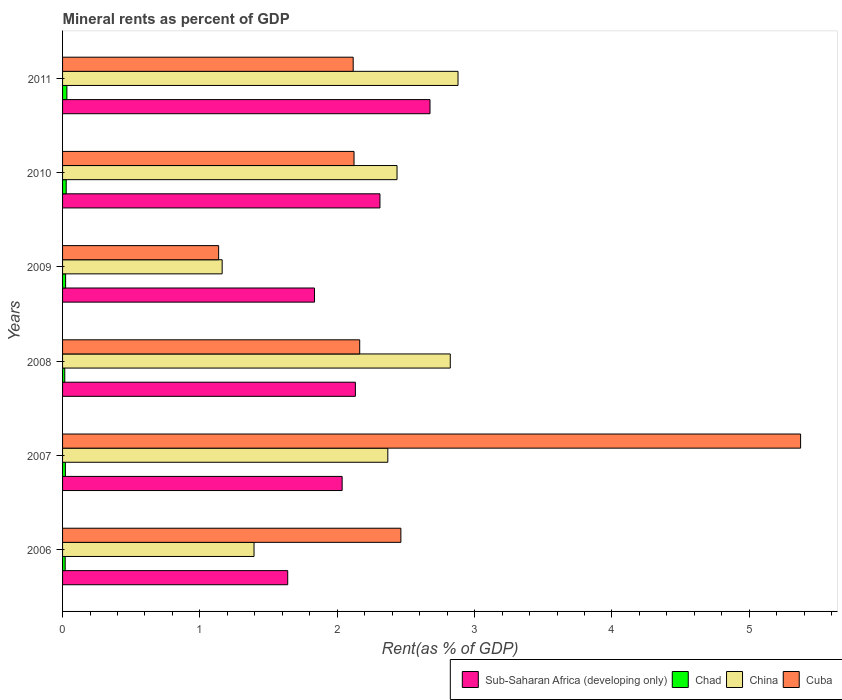How many different coloured bars are there?
Offer a terse response. 4. Are the number of bars per tick equal to the number of legend labels?
Keep it short and to the point. Yes. Are the number of bars on each tick of the Y-axis equal?
Keep it short and to the point. Yes. How many bars are there on the 1st tick from the bottom?
Your response must be concise. 4. What is the label of the 3rd group of bars from the top?
Give a very brief answer. 2009. What is the mineral rent in Cuba in 2008?
Your answer should be compact. 2.16. Across all years, what is the maximum mineral rent in Cuba?
Keep it short and to the point. 5.37. Across all years, what is the minimum mineral rent in China?
Offer a terse response. 1.16. What is the total mineral rent in China in the graph?
Keep it short and to the point. 13.06. What is the difference between the mineral rent in Sub-Saharan Africa (developing only) in 2006 and that in 2011?
Make the answer very short. -1.04. What is the difference between the mineral rent in Chad in 2006 and the mineral rent in China in 2009?
Offer a terse response. -1.14. What is the average mineral rent in Sub-Saharan Africa (developing only) per year?
Give a very brief answer. 2.1. In the year 2010, what is the difference between the mineral rent in Cuba and mineral rent in China?
Ensure brevity in your answer.  -0.31. In how many years, is the mineral rent in Chad greater than 1.8 %?
Provide a short and direct response. 0. What is the ratio of the mineral rent in Chad in 2006 to that in 2007?
Your answer should be compact. 0.93. What is the difference between the highest and the second highest mineral rent in Cuba?
Your answer should be very brief. 2.91. What is the difference between the highest and the lowest mineral rent in China?
Provide a succinct answer. 1.72. In how many years, is the mineral rent in Cuba greater than the average mineral rent in Cuba taken over all years?
Provide a short and direct response. 1. What does the 4th bar from the top in 2008 represents?
Keep it short and to the point. Sub-Saharan Africa (developing only). What does the 4th bar from the bottom in 2009 represents?
Make the answer very short. Cuba. How many bars are there?
Provide a short and direct response. 24. How many years are there in the graph?
Provide a short and direct response. 6. Does the graph contain grids?
Your answer should be compact. No. How many legend labels are there?
Your answer should be very brief. 4. What is the title of the graph?
Ensure brevity in your answer.  Mineral rents as percent of GDP. What is the label or title of the X-axis?
Ensure brevity in your answer.  Rent(as % of GDP). What is the label or title of the Y-axis?
Provide a short and direct response. Years. What is the Rent(as % of GDP) of Sub-Saharan Africa (developing only) in 2006?
Your answer should be very brief. 1.64. What is the Rent(as % of GDP) of Chad in 2006?
Keep it short and to the point. 0.02. What is the Rent(as % of GDP) in China in 2006?
Provide a short and direct response. 1.39. What is the Rent(as % of GDP) of Cuba in 2006?
Offer a very short reply. 2.46. What is the Rent(as % of GDP) in Sub-Saharan Africa (developing only) in 2007?
Provide a succinct answer. 2.04. What is the Rent(as % of GDP) of Chad in 2007?
Give a very brief answer. 0.02. What is the Rent(as % of GDP) in China in 2007?
Your answer should be very brief. 2.37. What is the Rent(as % of GDP) of Cuba in 2007?
Keep it short and to the point. 5.37. What is the Rent(as % of GDP) in Sub-Saharan Africa (developing only) in 2008?
Your response must be concise. 2.13. What is the Rent(as % of GDP) of Chad in 2008?
Make the answer very short. 0.02. What is the Rent(as % of GDP) in China in 2008?
Give a very brief answer. 2.82. What is the Rent(as % of GDP) in Cuba in 2008?
Keep it short and to the point. 2.16. What is the Rent(as % of GDP) in Sub-Saharan Africa (developing only) in 2009?
Give a very brief answer. 1.83. What is the Rent(as % of GDP) in Chad in 2009?
Offer a very short reply. 0.02. What is the Rent(as % of GDP) in China in 2009?
Provide a succinct answer. 1.16. What is the Rent(as % of GDP) in Cuba in 2009?
Make the answer very short. 1.14. What is the Rent(as % of GDP) of Sub-Saharan Africa (developing only) in 2010?
Your answer should be compact. 2.31. What is the Rent(as % of GDP) in Chad in 2010?
Your answer should be compact. 0.03. What is the Rent(as % of GDP) in China in 2010?
Your answer should be compact. 2.44. What is the Rent(as % of GDP) in Cuba in 2010?
Ensure brevity in your answer.  2.12. What is the Rent(as % of GDP) in Sub-Saharan Africa (developing only) in 2011?
Provide a succinct answer. 2.68. What is the Rent(as % of GDP) of Chad in 2011?
Make the answer very short. 0.03. What is the Rent(as % of GDP) of China in 2011?
Offer a very short reply. 2.88. What is the Rent(as % of GDP) of Cuba in 2011?
Your answer should be compact. 2.12. Across all years, what is the maximum Rent(as % of GDP) of Sub-Saharan Africa (developing only)?
Provide a short and direct response. 2.68. Across all years, what is the maximum Rent(as % of GDP) in Chad?
Your response must be concise. 0.03. Across all years, what is the maximum Rent(as % of GDP) in China?
Provide a succinct answer. 2.88. Across all years, what is the maximum Rent(as % of GDP) of Cuba?
Your response must be concise. 5.37. Across all years, what is the minimum Rent(as % of GDP) in Sub-Saharan Africa (developing only)?
Make the answer very short. 1.64. Across all years, what is the minimum Rent(as % of GDP) of Chad?
Provide a succinct answer. 0.02. Across all years, what is the minimum Rent(as % of GDP) of China?
Your response must be concise. 1.16. Across all years, what is the minimum Rent(as % of GDP) in Cuba?
Your response must be concise. 1.14. What is the total Rent(as % of GDP) in Sub-Saharan Africa (developing only) in the graph?
Provide a succinct answer. 12.63. What is the total Rent(as % of GDP) of Chad in the graph?
Provide a short and direct response. 0.14. What is the total Rent(as % of GDP) in China in the graph?
Keep it short and to the point. 13.06. What is the total Rent(as % of GDP) of Cuba in the graph?
Make the answer very short. 15.37. What is the difference between the Rent(as % of GDP) of Sub-Saharan Africa (developing only) in 2006 and that in 2007?
Keep it short and to the point. -0.4. What is the difference between the Rent(as % of GDP) in Chad in 2006 and that in 2007?
Give a very brief answer. -0. What is the difference between the Rent(as % of GDP) of China in 2006 and that in 2007?
Your answer should be very brief. -0.97. What is the difference between the Rent(as % of GDP) in Cuba in 2006 and that in 2007?
Your answer should be compact. -2.91. What is the difference between the Rent(as % of GDP) of Sub-Saharan Africa (developing only) in 2006 and that in 2008?
Offer a terse response. -0.49. What is the difference between the Rent(as % of GDP) of Chad in 2006 and that in 2008?
Ensure brevity in your answer.  0. What is the difference between the Rent(as % of GDP) of China in 2006 and that in 2008?
Your response must be concise. -1.43. What is the difference between the Rent(as % of GDP) of Cuba in 2006 and that in 2008?
Provide a short and direct response. 0.3. What is the difference between the Rent(as % of GDP) of Sub-Saharan Africa (developing only) in 2006 and that in 2009?
Make the answer very short. -0.19. What is the difference between the Rent(as % of GDP) of Chad in 2006 and that in 2009?
Offer a terse response. -0. What is the difference between the Rent(as % of GDP) in China in 2006 and that in 2009?
Give a very brief answer. 0.23. What is the difference between the Rent(as % of GDP) of Cuba in 2006 and that in 2009?
Keep it short and to the point. 1.33. What is the difference between the Rent(as % of GDP) in Sub-Saharan Africa (developing only) in 2006 and that in 2010?
Provide a succinct answer. -0.67. What is the difference between the Rent(as % of GDP) of Chad in 2006 and that in 2010?
Give a very brief answer. -0.01. What is the difference between the Rent(as % of GDP) in China in 2006 and that in 2010?
Your answer should be very brief. -1.04. What is the difference between the Rent(as % of GDP) of Cuba in 2006 and that in 2010?
Make the answer very short. 0.34. What is the difference between the Rent(as % of GDP) in Sub-Saharan Africa (developing only) in 2006 and that in 2011?
Provide a succinct answer. -1.04. What is the difference between the Rent(as % of GDP) in Chad in 2006 and that in 2011?
Provide a succinct answer. -0.01. What is the difference between the Rent(as % of GDP) of China in 2006 and that in 2011?
Provide a succinct answer. -1.49. What is the difference between the Rent(as % of GDP) in Cuba in 2006 and that in 2011?
Offer a terse response. 0.35. What is the difference between the Rent(as % of GDP) in Sub-Saharan Africa (developing only) in 2007 and that in 2008?
Provide a succinct answer. -0.1. What is the difference between the Rent(as % of GDP) of Chad in 2007 and that in 2008?
Provide a succinct answer. 0. What is the difference between the Rent(as % of GDP) of China in 2007 and that in 2008?
Make the answer very short. -0.45. What is the difference between the Rent(as % of GDP) in Cuba in 2007 and that in 2008?
Provide a succinct answer. 3.21. What is the difference between the Rent(as % of GDP) in Sub-Saharan Africa (developing only) in 2007 and that in 2009?
Give a very brief answer. 0.2. What is the difference between the Rent(as % of GDP) of Chad in 2007 and that in 2009?
Give a very brief answer. -0. What is the difference between the Rent(as % of GDP) of China in 2007 and that in 2009?
Make the answer very short. 1.21. What is the difference between the Rent(as % of GDP) in Cuba in 2007 and that in 2009?
Provide a short and direct response. 4.24. What is the difference between the Rent(as % of GDP) of Sub-Saharan Africa (developing only) in 2007 and that in 2010?
Make the answer very short. -0.28. What is the difference between the Rent(as % of GDP) of Chad in 2007 and that in 2010?
Provide a succinct answer. -0.01. What is the difference between the Rent(as % of GDP) of China in 2007 and that in 2010?
Give a very brief answer. -0.07. What is the difference between the Rent(as % of GDP) in Cuba in 2007 and that in 2010?
Offer a terse response. 3.25. What is the difference between the Rent(as % of GDP) of Sub-Saharan Africa (developing only) in 2007 and that in 2011?
Your answer should be very brief. -0.64. What is the difference between the Rent(as % of GDP) in Chad in 2007 and that in 2011?
Your answer should be very brief. -0.01. What is the difference between the Rent(as % of GDP) of China in 2007 and that in 2011?
Make the answer very short. -0.51. What is the difference between the Rent(as % of GDP) in Cuba in 2007 and that in 2011?
Your response must be concise. 3.26. What is the difference between the Rent(as % of GDP) of Sub-Saharan Africa (developing only) in 2008 and that in 2009?
Keep it short and to the point. 0.3. What is the difference between the Rent(as % of GDP) of Chad in 2008 and that in 2009?
Give a very brief answer. -0.01. What is the difference between the Rent(as % of GDP) in China in 2008 and that in 2009?
Your answer should be compact. 1.66. What is the difference between the Rent(as % of GDP) in Cuba in 2008 and that in 2009?
Keep it short and to the point. 1.03. What is the difference between the Rent(as % of GDP) of Sub-Saharan Africa (developing only) in 2008 and that in 2010?
Offer a very short reply. -0.18. What is the difference between the Rent(as % of GDP) in Chad in 2008 and that in 2010?
Offer a very short reply. -0.01. What is the difference between the Rent(as % of GDP) of China in 2008 and that in 2010?
Your response must be concise. 0.39. What is the difference between the Rent(as % of GDP) of Cuba in 2008 and that in 2010?
Give a very brief answer. 0.04. What is the difference between the Rent(as % of GDP) in Sub-Saharan Africa (developing only) in 2008 and that in 2011?
Your answer should be very brief. -0.54. What is the difference between the Rent(as % of GDP) in Chad in 2008 and that in 2011?
Provide a short and direct response. -0.02. What is the difference between the Rent(as % of GDP) in China in 2008 and that in 2011?
Offer a very short reply. -0.06. What is the difference between the Rent(as % of GDP) in Cuba in 2008 and that in 2011?
Offer a terse response. 0.05. What is the difference between the Rent(as % of GDP) in Sub-Saharan Africa (developing only) in 2009 and that in 2010?
Your answer should be very brief. -0.48. What is the difference between the Rent(as % of GDP) in Chad in 2009 and that in 2010?
Ensure brevity in your answer.  -0. What is the difference between the Rent(as % of GDP) in China in 2009 and that in 2010?
Offer a terse response. -1.27. What is the difference between the Rent(as % of GDP) of Cuba in 2009 and that in 2010?
Ensure brevity in your answer.  -0.99. What is the difference between the Rent(as % of GDP) in Sub-Saharan Africa (developing only) in 2009 and that in 2011?
Keep it short and to the point. -0.84. What is the difference between the Rent(as % of GDP) in Chad in 2009 and that in 2011?
Offer a very short reply. -0.01. What is the difference between the Rent(as % of GDP) in China in 2009 and that in 2011?
Ensure brevity in your answer.  -1.72. What is the difference between the Rent(as % of GDP) in Cuba in 2009 and that in 2011?
Offer a terse response. -0.98. What is the difference between the Rent(as % of GDP) of Sub-Saharan Africa (developing only) in 2010 and that in 2011?
Ensure brevity in your answer.  -0.36. What is the difference between the Rent(as % of GDP) of Chad in 2010 and that in 2011?
Make the answer very short. -0.01. What is the difference between the Rent(as % of GDP) of China in 2010 and that in 2011?
Provide a short and direct response. -0.44. What is the difference between the Rent(as % of GDP) in Cuba in 2010 and that in 2011?
Offer a very short reply. 0.01. What is the difference between the Rent(as % of GDP) of Sub-Saharan Africa (developing only) in 2006 and the Rent(as % of GDP) of Chad in 2007?
Give a very brief answer. 1.62. What is the difference between the Rent(as % of GDP) in Sub-Saharan Africa (developing only) in 2006 and the Rent(as % of GDP) in China in 2007?
Offer a terse response. -0.73. What is the difference between the Rent(as % of GDP) in Sub-Saharan Africa (developing only) in 2006 and the Rent(as % of GDP) in Cuba in 2007?
Your answer should be very brief. -3.73. What is the difference between the Rent(as % of GDP) in Chad in 2006 and the Rent(as % of GDP) in China in 2007?
Ensure brevity in your answer.  -2.35. What is the difference between the Rent(as % of GDP) in Chad in 2006 and the Rent(as % of GDP) in Cuba in 2007?
Keep it short and to the point. -5.35. What is the difference between the Rent(as % of GDP) of China in 2006 and the Rent(as % of GDP) of Cuba in 2007?
Keep it short and to the point. -3.98. What is the difference between the Rent(as % of GDP) in Sub-Saharan Africa (developing only) in 2006 and the Rent(as % of GDP) in Chad in 2008?
Offer a very short reply. 1.62. What is the difference between the Rent(as % of GDP) in Sub-Saharan Africa (developing only) in 2006 and the Rent(as % of GDP) in China in 2008?
Provide a short and direct response. -1.18. What is the difference between the Rent(as % of GDP) in Sub-Saharan Africa (developing only) in 2006 and the Rent(as % of GDP) in Cuba in 2008?
Keep it short and to the point. -0.52. What is the difference between the Rent(as % of GDP) in Chad in 2006 and the Rent(as % of GDP) in China in 2008?
Your response must be concise. -2.8. What is the difference between the Rent(as % of GDP) in Chad in 2006 and the Rent(as % of GDP) in Cuba in 2008?
Offer a terse response. -2.14. What is the difference between the Rent(as % of GDP) in China in 2006 and the Rent(as % of GDP) in Cuba in 2008?
Provide a succinct answer. -0.77. What is the difference between the Rent(as % of GDP) of Sub-Saharan Africa (developing only) in 2006 and the Rent(as % of GDP) of Chad in 2009?
Your answer should be very brief. 1.62. What is the difference between the Rent(as % of GDP) in Sub-Saharan Africa (developing only) in 2006 and the Rent(as % of GDP) in China in 2009?
Your answer should be very brief. 0.48. What is the difference between the Rent(as % of GDP) of Sub-Saharan Africa (developing only) in 2006 and the Rent(as % of GDP) of Cuba in 2009?
Your response must be concise. 0.5. What is the difference between the Rent(as % of GDP) of Chad in 2006 and the Rent(as % of GDP) of China in 2009?
Give a very brief answer. -1.14. What is the difference between the Rent(as % of GDP) in Chad in 2006 and the Rent(as % of GDP) in Cuba in 2009?
Keep it short and to the point. -1.12. What is the difference between the Rent(as % of GDP) in China in 2006 and the Rent(as % of GDP) in Cuba in 2009?
Ensure brevity in your answer.  0.26. What is the difference between the Rent(as % of GDP) of Sub-Saharan Africa (developing only) in 2006 and the Rent(as % of GDP) of Chad in 2010?
Your answer should be very brief. 1.61. What is the difference between the Rent(as % of GDP) in Sub-Saharan Africa (developing only) in 2006 and the Rent(as % of GDP) in China in 2010?
Your response must be concise. -0.8. What is the difference between the Rent(as % of GDP) of Sub-Saharan Africa (developing only) in 2006 and the Rent(as % of GDP) of Cuba in 2010?
Make the answer very short. -0.48. What is the difference between the Rent(as % of GDP) of Chad in 2006 and the Rent(as % of GDP) of China in 2010?
Keep it short and to the point. -2.42. What is the difference between the Rent(as % of GDP) of Chad in 2006 and the Rent(as % of GDP) of Cuba in 2010?
Keep it short and to the point. -2.1. What is the difference between the Rent(as % of GDP) in China in 2006 and the Rent(as % of GDP) in Cuba in 2010?
Your answer should be very brief. -0.73. What is the difference between the Rent(as % of GDP) in Sub-Saharan Africa (developing only) in 2006 and the Rent(as % of GDP) in Chad in 2011?
Give a very brief answer. 1.61. What is the difference between the Rent(as % of GDP) in Sub-Saharan Africa (developing only) in 2006 and the Rent(as % of GDP) in China in 2011?
Keep it short and to the point. -1.24. What is the difference between the Rent(as % of GDP) of Sub-Saharan Africa (developing only) in 2006 and the Rent(as % of GDP) of Cuba in 2011?
Your response must be concise. -0.48. What is the difference between the Rent(as % of GDP) in Chad in 2006 and the Rent(as % of GDP) in China in 2011?
Your answer should be compact. -2.86. What is the difference between the Rent(as % of GDP) of Chad in 2006 and the Rent(as % of GDP) of Cuba in 2011?
Give a very brief answer. -2.1. What is the difference between the Rent(as % of GDP) of China in 2006 and the Rent(as % of GDP) of Cuba in 2011?
Make the answer very short. -0.72. What is the difference between the Rent(as % of GDP) in Sub-Saharan Africa (developing only) in 2007 and the Rent(as % of GDP) in Chad in 2008?
Your answer should be very brief. 2.02. What is the difference between the Rent(as % of GDP) of Sub-Saharan Africa (developing only) in 2007 and the Rent(as % of GDP) of China in 2008?
Provide a short and direct response. -0.79. What is the difference between the Rent(as % of GDP) in Sub-Saharan Africa (developing only) in 2007 and the Rent(as % of GDP) in Cuba in 2008?
Your answer should be compact. -0.13. What is the difference between the Rent(as % of GDP) in Chad in 2007 and the Rent(as % of GDP) in China in 2008?
Provide a short and direct response. -2.8. What is the difference between the Rent(as % of GDP) in Chad in 2007 and the Rent(as % of GDP) in Cuba in 2008?
Ensure brevity in your answer.  -2.14. What is the difference between the Rent(as % of GDP) of China in 2007 and the Rent(as % of GDP) of Cuba in 2008?
Your answer should be very brief. 0.2. What is the difference between the Rent(as % of GDP) of Sub-Saharan Africa (developing only) in 2007 and the Rent(as % of GDP) of Chad in 2009?
Your answer should be very brief. 2.01. What is the difference between the Rent(as % of GDP) of Sub-Saharan Africa (developing only) in 2007 and the Rent(as % of GDP) of China in 2009?
Your response must be concise. 0.87. What is the difference between the Rent(as % of GDP) in Sub-Saharan Africa (developing only) in 2007 and the Rent(as % of GDP) in Cuba in 2009?
Provide a short and direct response. 0.9. What is the difference between the Rent(as % of GDP) in Chad in 2007 and the Rent(as % of GDP) in China in 2009?
Offer a very short reply. -1.14. What is the difference between the Rent(as % of GDP) of Chad in 2007 and the Rent(as % of GDP) of Cuba in 2009?
Ensure brevity in your answer.  -1.12. What is the difference between the Rent(as % of GDP) of China in 2007 and the Rent(as % of GDP) of Cuba in 2009?
Offer a terse response. 1.23. What is the difference between the Rent(as % of GDP) in Sub-Saharan Africa (developing only) in 2007 and the Rent(as % of GDP) in Chad in 2010?
Offer a terse response. 2.01. What is the difference between the Rent(as % of GDP) of Sub-Saharan Africa (developing only) in 2007 and the Rent(as % of GDP) of China in 2010?
Ensure brevity in your answer.  -0.4. What is the difference between the Rent(as % of GDP) in Sub-Saharan Africa (developing only) in 2007 and the Rent(as % of GDP) in Cuba in 2010?
Provide a short and direct response. -0.09. What is the difference between the Rent(as % of GDP) in Chad in 2007 and the Rent(as % of GDP) in China in 2010?
Your answer should be compact. -2.41. What is the difference between the Rent(as % of GDP) of Chad in 2007 and the Rent(as % of GDP) of Cuba in 2010?
Offer a terse response. -2.1. What is the difference between the Rent(as % of GDP) of China in 2007 and the Rent(as % of GDP) of Cuba in 2010?
Offer a terse response. 0.25. What is the difference between the Rent(as % of GDP) in Sub-Saharan Africa (developing only) in 2007 and the Rent(as % of GDP) in Chad in 2011?
Your response must be concise. 2. What is the difference between the Rent(as % of GDP) of Sub-Saharan Africa (developing only) in 2007 and the Rent(as % of GDP) of China in 2011?
Your answer should be very brief. -0.84. What is the difference between the Rent(as % of GDP) of Sub-Saharan Africa (developing only) in 2007 and the Rent(as % of GDP) of Cuba in 2011?
Provide a short and direct response. -0.08. What is the difference between the Rent(as % of GDP) in Chad in 2007 and the Rent(as % of GDP) in China in 2011?
Give a very brief answer. -2.86. What is the difference between the Rent(as % of GDP) of Chad in 2007 and the Rent(as % of GDP) of Cuba in 2011?
Provide a succinct answer. -2.1. What is the difference between the Rent(as % of GDP) in China in 2007 and the Rent(as % of GDP) in Cuba in 2011?
Your answer should be compact. 0.25. What is the difference between the Rent(as % of GDP) in Sub-Saharan Africa (developing only) in 2008 and the Rent(as % of GDP) in Chad in 2009?
Offer a very short reply. 2.11. What is the difference between the Rent(as % of GDP) of Chad in 2008 and the Rent(as % of GDP) of China in 2009?
Provide a succinct answer. -1.15. What is the difference between the Rent(as % of GDP) of Chad in 2008 and the Rent(as % of GDP) of Cuba in 2009?
Ensure brevity in your answer.  -1.12. What is the difference between the Rent(as % of GDP) of China in 2008 and the Rent(as % of GDP) of Cuba in 2009?
Offer a very short reply. 1.69. What is the difference between the Rent(as % of GDP) in Sub-Saharan Africa (developing only) in 2008 and the Rent(as % of GDP) in Chad in 2010?
Ensure brevity in your answer.  2.11. What is the difference between the Rent(as % of GDP) of Sub-Saharan Africa (developing only) in 2008 and the Rent(as % of GDP) of China in 2010?
Ensure brevity in your answer.  -0.3. What is the difference between the Rent(as % of GDP) of Sub-Saharan Africa (developing only) in 2008 and the Rent(as % of GDP) of Cuba in 2010?
Ensure brevity in your answer.  0.01. What is the difference between the Rent(as % of GDP) in Chad in 2008 and the Rent(as % of GDP) in China in 2010?
Provide a succinct answer. -2.42. What is the difference between the Rent(as % of GDP) in Chad in 2008 and the Rent(as % of GDP) in Cuba in 2010?
Offer a very short reply. -2.11. What is the difference between the Rent(as % of GDP) in China in 2008 and the Rent(as % of GDP) in Cuba in 2010?
Make the answer very short. 0.7. What is the difference between the Rent(as % of GDP) of Sub-Saharan Africa (developing only) in 2008 and the Rent(as % of GDP) of Chad in 2011?
Ensure brevity in your answer.  2.1. What is the difference between the Rent(as % of GDP) of Sub-Saharan Africa (developing only) in 2008 and the Rent(as % of GDP) of China in 2011?
Offer a very short reply. -0.75. What is the difference between the Rent(as % of GDP) in Sub-Saharan Africa (developing only) in 2008 and the Rent(as % of GDP) in Cuba in 2011?
Your response must be concise. 0.02. What is the difference between the Rent(as % of GDP) of Chad in 2008 and the Rent(as % of GDP) of China in 2011?
Ensure brevity in your answer.  -2.86. What is the difference between the Rent(as % of GDP) of China in 2008 and the Rent(as % of GDP) of Cuba in 2011?
Offer a terse response. 0.71. What is the difference between the Rent(as % of GDP) in Sub-Saharan Africa (developing only) in 2009 and the Rent(as % of GDP) in Chad in 2010?
Offer a very short reply. 1.81. What is the difference between the Rent(as % of GDP) of Sub-Saharan Africa (developing only) in 2009 and the Rent(as % of GDP) of China in 2010?
Keep it short and to the point. -0.6. What is the difference between the Rent(as % of GDP) in Sub-Saharan Africa (developing only) in 2009 and the Rent(as % of GDP) in Cuba in 2010?
Keep it short and to the point. -0.29. What is the difference between the Rent(as % of GDP) in Chad in 2009 and the Rent(as % of GDP) in China in 2010?
Ensure brevity in your answer.  -2.41. What is the difference between the Rent(as % of GDP) in Chad in 2009 and the Rent(as % of GDP) in Cuba in 2010?
Give a very brief answer. -2.1. What is the difference between the Rent(as % of GDP) in China in 2009 and the Rent(as % of GDP) in Cuba in 2010?
Your response must be concise. -0.96. What is the difference between the Rent(as % of GDP) of Sub-Saharan Africa (developing only) in 2009 and the Rent(as % of GDP) of Chad in 2011?
Your answer should be compact. 1.8. What is the difference between the Rent(as % of GDP) in Sub-Saharan Africa (developing only) in 2009 and the Rent(as % of GDP) in China in 2011?
Provide a short and direct response. -1.04. What is the difference between the Rent(as % of GDP) in Sub-Saharan Africa (developing only) in 2009 and the Rent(as % of GDP) in Cuba in 2011?
Give a very brief answer. -0.28. What is the difference between the Rent(as % of GDP) of Chad in 2009 and the Rent(as % of GDP) of China in 2011?
Provide a succinct answer. -2.86. What is the difference between the Rent(as % of GDP) of Chad in 2009 and the Rent(as % of GDP) of Cuba in 2011?
Provide a succinct answer. -2.09. What is the difference between the Rent(as % of GDP) in China in 2009 and the Rent(as % of GDP) in Cuba in 2011?
Keep it short and to the point. -0.95. What is the difference between the Rent(as % of GDP) of Sub-Saharan Africa (developing only) in 2010 and the Rent(as % of GDP) of Chad in 2011?
Your answer should be compact. 2.28. What is the difference between the Rent(as % of GDP) in Sub-Saharan Africa (developing only) in 2010 and the Rent(as % of GDP) in China in 2011?
Offer a terse response. -0.57. What is the difference between the Rent(as % of GDP) in Sub-Saharan Africa (developing only) in 2010 and the Rent(as % of GDP) in Cuba in 2011?
Make the answer very short. 0.19. What is the difference between the Rent(as % of GDP) of Chad in 2010 and the Rent(as % of GDP) of China in 2011?
Your response must be concise. -2.85. What is the difference between the Rent(as % of GDP) in Chad in 2010 and the Rent(as % of GDP) in Cuba in 2011?
Your answer should be very brief. -2.09. What is the difference between the Rent(as % of GDP) of China in 2010 and the Rent(as % of GDP) of Cuba in 2011?
Your answer should be compact. 0.32. What is the average Rent(as % of GDP) in Sub-Saharan Africa (developing only) per year?
Your answer should be compact. 2.1. What is the average Rent(as % of GDP) in Chad per year?
Offer a terse response. 0.02. What is the average Rent(as % of GDP) of China per year?
Provide a succinct answer. 2.18. What is the average Rent(as % of GDP) of Cuba per year?
Provide a succinct answer. 2.56. In the year 2006, what is the difference between the Rent(as % of GDP) of Sub-Saharan Africa (developing only) and Rent(as % of GDP) of Chad?
Your answer should be compact. 1.62. In the year 2006, what is the difference between the Rent(as % of GDP) in Sub-Saharan Africa (developing only) and Rent(as % of GDP) in China?
Provide a short and direct response. 0.25. In the year 2006, what is the difference between the Rent(as % of GDP) of Sub-Saharan Africa (developing only) and Rent(as % of GDP) of Cuba?
Provide a short and direct response. -0.82. In the year 2006, what is the difference between the Rent(as % of GDP) of Chad and Rent(as % of GDP) of China?
Your answer should be very brief. -1.38. In the year 2006, what is the difference between the Rent(as % of GDP) of Chad and Rent(as % of GDP) of Cuba?
Your answer should be compact. -2.44. In the year 2006, what is the difference between the Rent(as % of GDP) of China and Rent(as % of GDP) of Cuba?
Your answer should be very brief. -1.07. In the year 2007, what is the difference between the Rent(as % of GDP) of Sub-Saharan Africa (developing only) and Rent(as % of GDP) of Chad?
Make the answer very short. 2.02. In the year 2007, what is the difference between the Rent(as % of GDP) in Sub-Saharan Africa (developing only) and Rent(as % of GDP) in China?
Ensure brevity in your answer.  -0.33. In the year 2007, what is the difference between the Rent(as % of GDP) in Sub-Saharan Africa (developing only) and Rent(as % of GDP) in Cuba?
Ensure brevity in your answer.  -3.34. In the year 2007, what is the difference between the Rent(as % of GDP) in Chad and Rent(as % of GDP) in China?
Provide a short and direct response. -2.35. In the year 2007, what is the difference between the Rent(as % of GDP) in Chad and Rent(as % of GDP) in Cuba?
Your answer should be very brief. -5.35. In the year 2007, what is the difference between the Rent(as % of GDP) in China and Rent(as % of GDP) in Cuba?
Ensure brevity in your answer.  -3.01. In the year 2008, what is the difference between the Rent(as % of GDP) in Sub-Saharan Africa (developing only) and Rent(as % of GDP) in Chad?
Keep it short and to the point. 2.12. In the year 2008, what is the difference between the Rent(as % of GDP) in Sub-Saharan Africa (developing only) and Rent(as % of GDP) in China?
Your answer should be compact. -0.69. In the year 2008, what is the difference between the Rent(as % of GDP) of Sub-Saharan Africa (developing only) and Rent(as % of GDP) of Cuba?
Ensure brevity in your answer.  -0.03. In the year 2008, what is the difference between the Rent(as % of GDP) of Chad and Rent(as % of GDP) of China?
Provide a short and direct response. -2.81. In the year 2008, what is the difference between the Rent(as % of GDP) in Chad and Rent(as % of GDP) in Cuba?
Offer a terse response. -2.15. In the year 2008, what is the difference between the Rent(as % of GDP) in China and Rent(as % of GDP) in Cuba?
Ensure brevity in your answer.  0.66. In the year 2009, what is the difference between the Rent(as % of GDP) of Sub-Saharan Africa (developing only) and Rent(as % of GDP) of Chad?
Ensure brevity in your answer.  1.81. In the year 2009, what is the difference between the Rent(as % of GDP) in Sub-Saharan Africa (developing only) and Rent(as % of GDP) in China?
Your response must be concise. 0.67. In the year 2009, what is the difference between the Rent(as % of GDP) in Sub-Saharan Africa (developing only) and Rent(as % of GDP) in Cuba?
Give a very brief answer. 0.7. In the year 2009, what is the difference between the Rent(as % of GDP) in Chad and Rent(as % of GDP) in China?
Offer a terse response. -1.14. In the year 2009, what is the difference between the Rent(as % of GDP) of Chad and Rent(as % of GDP) of Cuba?
Provide a short and direct response. -1.11. In the year 2009, what is the difference between the Rent(as % of GDP) of China and Rent(as % of GDP) of Cuba?
Offer a very short reply. 0.03. In the year 2010, what is the difference between the Rent(as % of GDP) in Sub-Saharan Africa (developing only) and Rent(as % of GDP) in Chad?
Provide a short and direct response. 2.28. In the year 2010, what is the difference between the Rent(as % of GDP) of Sub-Saharan Africa (developing only) and Rent(as % of GDP) of China?
Ensure brevity in your answer.  -0.12. In the year 2010, what is the difference between the Rent(as % of GDP) of Sub-Saharan Africa (developing only) and Rent(as % of GDP) of Cuba?
Your answer should be very brief. 0.19. In the year 2010, what is the difference between the Rent(as % of GDP) of Chad and Rent(as % of GDP) of China?
Make the answer very short. -2.41. In the year 2010, what is the difference between the Rent(as % of GDP) of Chad and Rent(as % of GDP) of Cuba?
Offer a very short reply. -2.1. In the year 2010, what is the difference between the Rent(as % of GDP) in China and Rent(as % of GDP) in Cuba?
Provide a succinct answer. 0.31. In the year 2011, what is the difference between the Rent(as % of GDP) in Sub-Saharan Africa (developing only) and Rent(as % of GDP) in Chad?
Offer a terse response. 2.64. In the year 2011, what is the difference between the Rent(as % of GDP) in Sub-Saharan Africa (developing only) and Rent(as % of GDP) in China?
Provide a succinct answer. -0.2. In the year 2011, what is the difference between the Rent(as % of GDP) of Sub-Saharan Africa (developing only) and Rent(as % of GDP) of Cuba?
Make the answer very short. 0.56. In the year 2011, what is the difference between the Rent(as % of GDP) of Chad and Rent(as % of GDP) of China?
Ensure brevity in your answer.  -2.85. In the year 2011, what is the difference between the Rent(as % of GDP) of Chad and Rent(as % of GDP) of Cuba?
Offer a very short reply. -2.08. In the year 2011, what is the difference between the Rent(as % of GDP) in China and Rent(as % of GDP) in Cuba?
Provide a short and direct response. 0.76. What is the ratio of the Rent(as % of GDP) in Sub-Saharan Africa (developing only) in 2006 to that in 2007?
Offer a terse response. 0.81. What is the ratio of the Rent(as % of GDP) in Chad in 2006 to that in 2007?
Provide a short and direct response. 0.93. What is the ratio of the Rent(as % of GDP) in China in 2006 to that in 2007?
Provide a succinct answer. 0.59. What is the ratio of the Rent(as % of GDP) of Cuba in 2006 to that in 2007?
Your answer should be compact. 0.46. What is the ratio of the Rent(as % of GDP) in Sub-Saharan Africa (developing only) in 2006 to that in 2008?
Offer a very short reply. 0.77. What is the ratio of the Rent(as % of GDP) of Chad in 2006 to that in 2008?
Your response must be concise. 1.19. What is the ratio of the Rent(as % of GDP) of China in 2006 to that in 2008?
Your answer should be compact. 0.49. What is the ratio of the Rent(as % of GDP) in Cuba in 2006 to that in 2008?
Offer a very short reply. 1.14. What is the ratio of the Rent(as % of GDP) of Sub-Saharan Africa (developing only) in 2006 to that in 2009?
Your answer should be very brief. 0.89. What is the ratio of the Rent(as % of GDP) in Chad in 2006 to that in 2009?
Provide a succinct answer. 0.86. What is the ratio of the Rent(as % of GDP) in China in 2006 to that in 2009?
Provide a short and direct response. 1.2. What is the ratio of the Rent(as % of GDP) of Cuba in 2006 to that in 2009?
Your response must be concise. 2.17. What is the ratio of the Rent(as % of GDP) of Sub-Saharan Africa (developing only) in 2006 to that in 2010?
Your answer should be very brief. 0.71. What is the ratio of the Rent(as % of GDP) of Chad in 2006 to that in 2010?
Keep it short and to the point. 0.72. What is the ratio of the Rent(as % of GDP) of China in 2006 to that in 2010?
Your response must be concise. 0.57. What is the ratio of the Rent(as % of GDP) in Cuba in 2006 to that in 2010?
Give a very brief answer. 1.16. What is the ratio of the Rent(as % of GDP) of Sub-Saharan Africa (developing only) in 2006 to that in 2011?
Give a very brief answer. 0.61. What is the ratio of the Rent(as % of GDP) in Chad in 2006 to that in 2011?
Provide a short and direct response. 0.6. What is the ratio of the Rent(as % of GDP) of China in 2006 to that in 2011?
Give a very brief answer. 0.48. What is the ratio of the Rent(as % of GDP) in Cuba in 2006 to that in 2011?
Keep it short and to the point. 1.16. What is the ratio of the Rent(as % of GDP) of Sub-Saharan Africa (developing only) in 2007 to that in 2008?
Provide a succinct answer. 0.95. What is the ratio of the Rent(as % of GDP) in Chad in 2007 to that in 2008?
Provide a succinct answer. 1.28. What is the ratio of the Rent(as % of GDP) in China in 2007 to that in 2008?
Your answer should be very brief. 0.84. What is the ratio of the Rent(as % of GDP) of Cuba in 2007 to that in 2008?
Make the answer very short. 2.48. What is the ratio of the Rent(as % of GDP) in Sub-Saharan Africa (developing only) in 2007 to that in 2009?
Your response must be concise. 1.11. What is the ratio of the Rent(as % of GDP) of Chad in 2007 to that in 2009?
Keep it short and to the point. 0.92. What is the ratio of the Rent(as % of GDP) in China in 2007 to that in 2009?
Your answer should be very brief. 2.04. What is the ratio of the Rent(as % of GDP) in Cuba in 2007 to that in 2009?
Keep it short and to the point. 4.73. What is the ratio of the Rent(as % of GDP) of Sub-Saharan Africa (developing only) in 2007 to that in 2010?
Keep it short and to the point. 0.88. What is the ratio of the Rent(as % of GDP) of Chad in 2007 to that in 2010?
Offer a terse response. 0.77. What is the ratio of the Rent(as % of GDP) of China in 2007 to that in 2010?
Offer a very short reply. 0.97. What is the ratio of the Rent(as % of GDP) in Cuba in 2007 to that in 2010?
Give a very brief answer. 2.53. What is the ratio of the Rent(as % of GDP) of Sub-Saharan Africa (developing only) in 2007 to that in 2011?
Ensure brevity in your answer.  0.76. What is the ratio of the Rent(as % of GDP) of Chad in 2007 to that in 2011?
Provide a succinct answer. 0.65. What is the ratio of the Rent(as % of GDP) of China in 2007 to that in 2011?
Offer a very short reply. 0.82. What is the ratio of the Rent(as % of GDP) in Cuba in 2007 to that in 2011?
Provide a short and direct response. 2.54. What is the ratio of the Rent(as % of GDP) of Sub-Saharan Africa (developing only) in 2008 to that in 2009?
Ensure brevity in your answer.  1.16. What is the ratio of the Rent(as % of GDP) of Chad in 2008 to that in 2009?
Ensure brevity in your answer.  0.72. What is the ratio of the Rent(as % of GDP) in China in 2008 to that in 2009?
Give a very brief answer. 2.43. What is the ratio of the Rent(as % of GDP) of Cuba in 2008 to that in 2009?
Ensure brevity in your answer.  1.9. What is the ratio of the Rent(as % of GDP) in Sub-Saharan Africa (developing only) in 2008 to that in 2010?
Provide a succinct answer. 0.92. What is the ratio of the Rent(as % of GDP) of Chad in 2008 to that in 2010?
Ensure brevity in your answer.  0.6. What is the ratio of the Rent(as % of GDP) in China in 2008 to that in 2010?
Keep it short and to the point. 1.16. What is the ratio of the Rent(as % of GDP) of Cuba in 2008 to that in 2010?
Offer a terse response. 1.02. What is the ratio of the Rent(as % of GDP) of Sub-Saharan Africa (developing only) in 2008 to that in 2011?
Your response must be concise. 0.8. What is the ratio of the Rent(as % of GDP) of Chad in 2008 to that in 2011?
Give a very brief answer. 0.51. What is the ratio of the Rent(as % of GDP) of China in 2008 to that in 2011?
Provide a succinct answer. 0.98. What is the ratio of the Rent(as % of GDP) in Cuba in 2008 to that in 2011?
Offer a terse response. 1.02. What is the ratio of the Rent(as % of GDP) of Sub-Saharan Africa (developing only) in 2009 to that in 2010?
Make the answer very short. 0.79. What is the ratio of the Rent(as % of GDP) of Chad in 2009 to that in 2010?
Provide a short and direct response. 0.84. What is the ratio of the Rent(as % of GDP) of China in 2009 to that in 2010?
Keep it short and to the point. 0.48. What is the ratio of the Rent(as % of GDP) of Cuba in 2009 to that in 2010?
Your response must be concise. 0.54. What is the ratio of the Rent(as % of GDP) in Sub-Saharan Africa (developing only) in 2009 to that in 2011?
Your answer should be compact. 0.69. What is the ratio of the Rent(as % of GDP) of Chad in 2009 to that in 2011?
Provide a short and direct response. 0.7. What is the ratio of the Rent(as % of GDP) of China in 2009 to that in 2011?
Provide a succinct answer. 0.4. What is the ratio of the Rent(as % of GDP) of Cuba in 2009 to that in 2011?
Keep it short and to the point. 0.54. What is the ratio of the Rent(as % of GDP) of Sub-Saharan Africa (developing only) in 2010 to that in 2011?
Give a very brief answer. 0.86. What is the ratio of the Rent(as % of GDP) of Chad in 2010 to that in 2011?
Provide a short and direct response. 0.84. What is the ratio of the Rent(as % of GDP) of China in 2010 to that in 2011?
Make the answer very short. 0.85. What is the difference between the highest and the second highest Rent(as % of GDP) of Sub-Saharan Africa (developing only)?
Keep it short and to the point. 0.36. What is the difference between the highest and the second highest Rent(as % of GDP) of Chad?
Provide a succinct answer. 0.01. What is the difference between the highest and the second highest Rent(as % of GDP) in China?
Make the answer very short. 0.06. What is the difference between the highest and the second highest Rent(as % of GDP) in Cuba?
Provide a succinct answer. 2.91. What is the difference between the highest and the lowest Rent(as % of GDP) of Sub-Saharan Africa (developing only)?
Your answer should be very brief. 1.04. What is the difference between the highest and the lowest Rent(as % of GDP) in Chad?
Provide a succinct answer. 0.02. What is the difference between the highest and the lowest Rent(as % of GDP) of China?
Your response must be concise. 1.72. What is the difference between the highest and the lowest Rent(as % of GDP) in Cuba?
Your answer should be very brief. 4.24. 